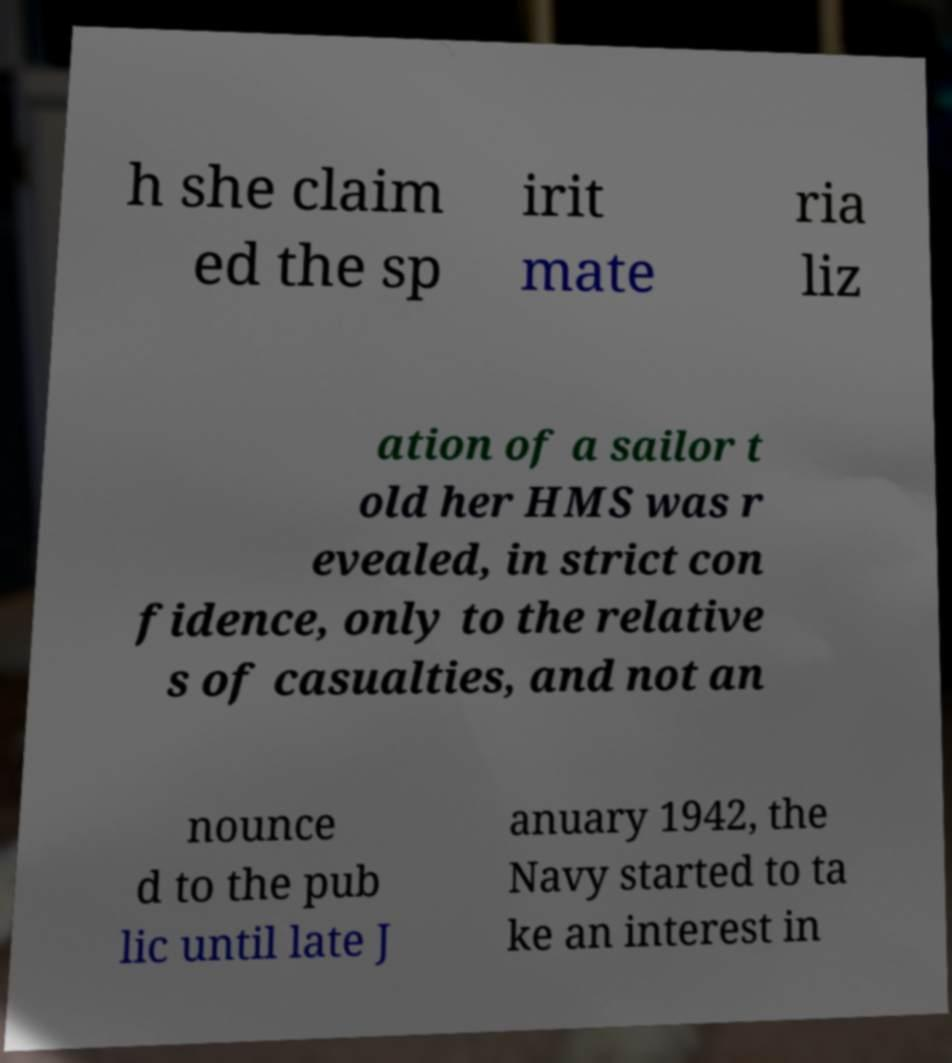Could you extract and type out the text from this image? h she claim ed the sp irit mate ria liz ation of a sailor t old her HMS was r evealed, in strict con fidence, only to the relative s of casualties, and not an nounce d to the pub lic until late J anuary 1942, the Navy started to ta ke an interest in 